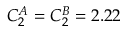<formula> <loc_0><loc_0><loc_500><loc_500>C _ { 2 } ^ { A } = C _ { 2 } ^ { B } = 2 . 2 2</formula> 